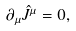Convert formula to latex. <formula><loc_0><loc_0><loc_500><loc_500>\partial _ { \mu } \hat { J } ^ { \mu } = 0 ,</formula> 